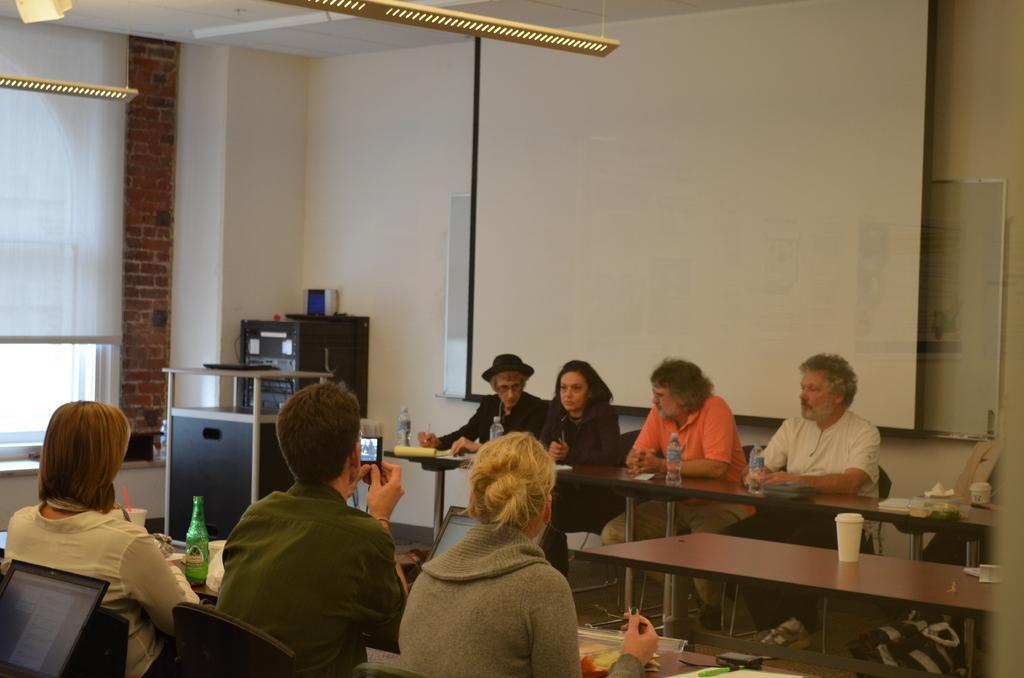Describe this image in one or two sentences. The picture is taken in a room. In the foreground of the picture there are people sitting in chairs and there are tables, bottles, cups, food items, laptop and other objects. In the center of the picture there are tables, water bottles, books, pens, desks and other objects. In the background there is a projector screen. On the left there is a window and window blind. 